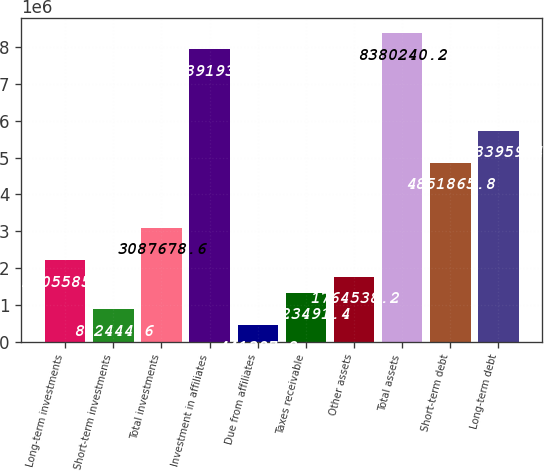Convert chart to OTSL. <chart><loc_0><loc_0><loc_500><loc_500><bar_chart><fcel>Long-term investments<fcel>Short-term investments<fcel>Total investments<fcel>Investment in affiliates<fcel>Due from affiliates<fcel>Taxes receivable<fcel>Other assets<fcel>Total assets<fcel>Short-term debt<fcel>Long-term debt<nl><fcel>2.20558e+06<fcel>882445<fcel>3.08768e+06<fcel>7.93919e+06<fcel>441398<fcel>1.32349e+06<fcel>1.76454e+06<fcel>8.38024e+06<fcel>4.85187e+06<fcel>5.73396e+06<nl></chart> 